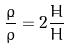Convert formula to latex. <formula><loc_0><loc_0><loc_500><loc_500>\frac { \dot { \rho } } { \rho } = 2 \frac { \dot { H } } { H }</formula> 